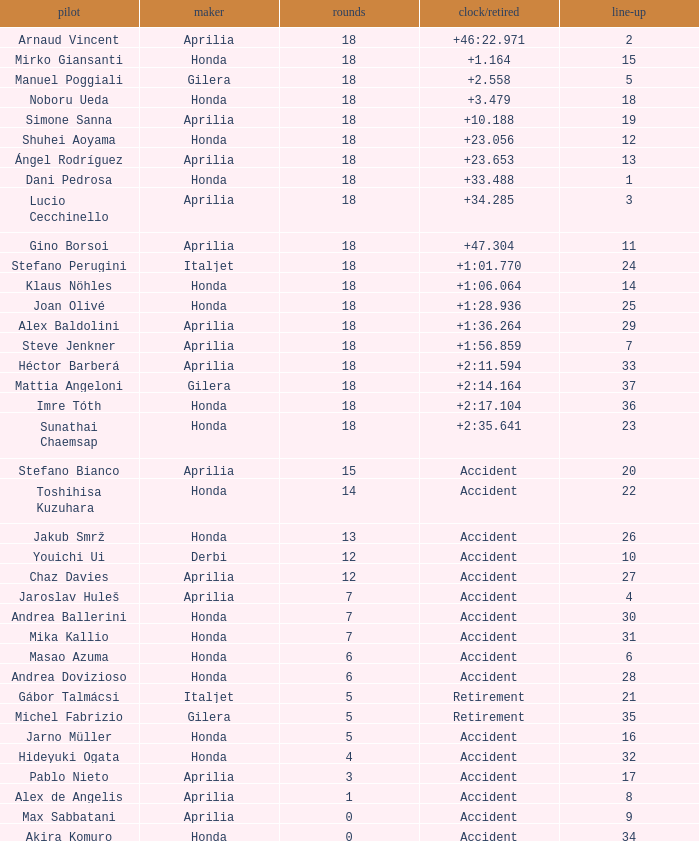What is the time/retired of the honda manufacturer with a grid less than 26, 18 laps, and joan olivé as the rider? +1:28.936. 